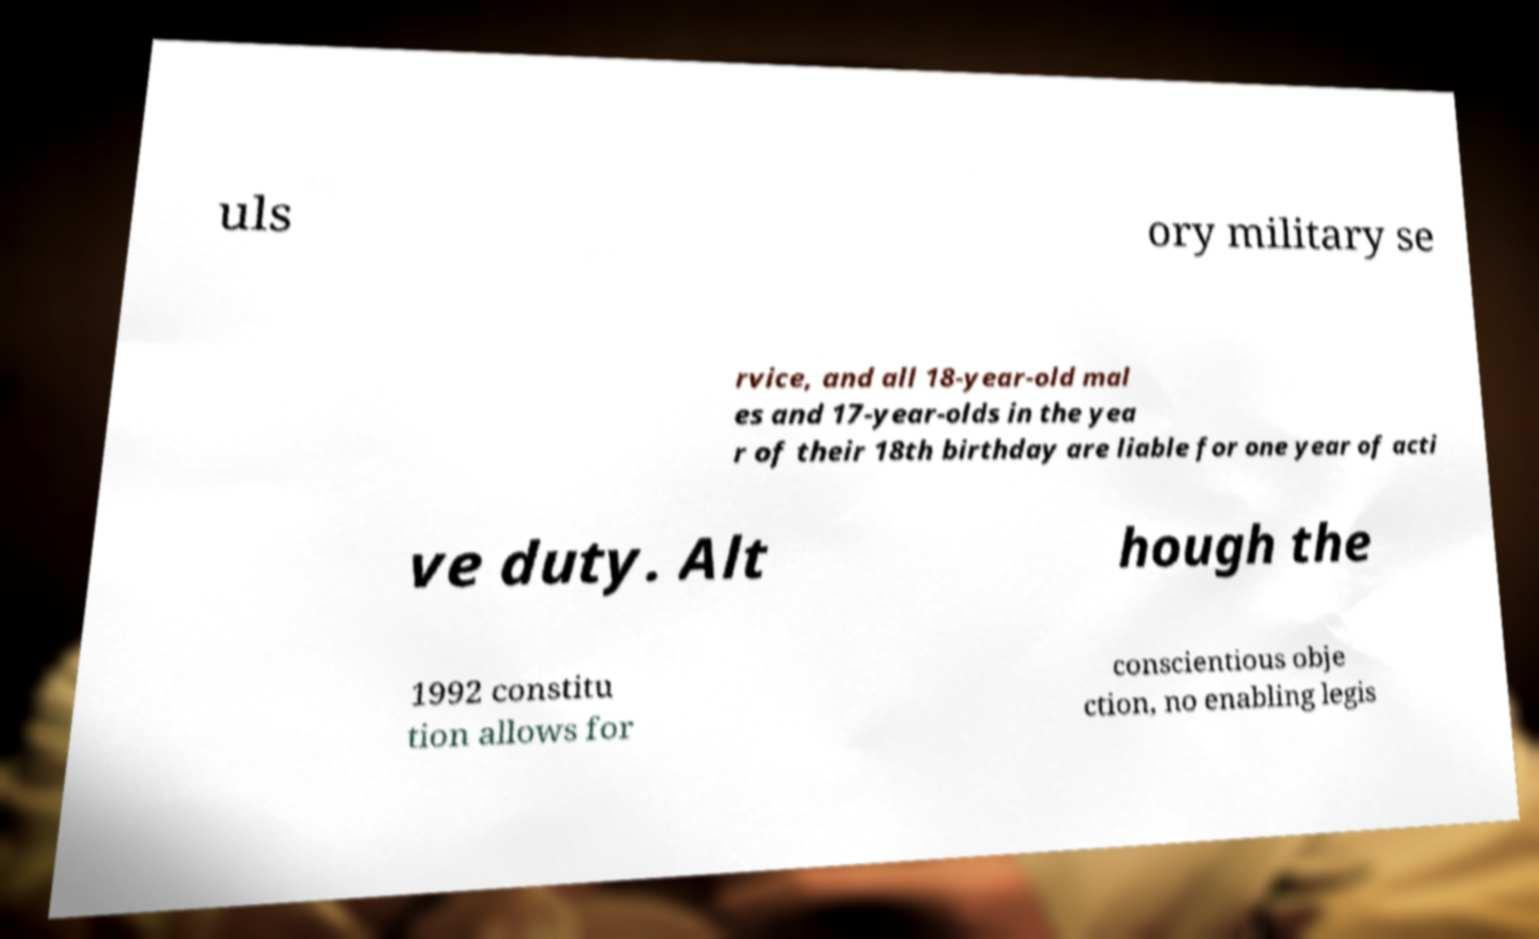Please identify and transcribe the text found in this image. uls ory military se rvice, and all 18-year-old mal es and 17-year-olds in the yea r of their 18th birthday are liable for one year of acti ve duty. Alt hough the 1992 constitu tion allows for conscientious obje ction, no enabling legis 